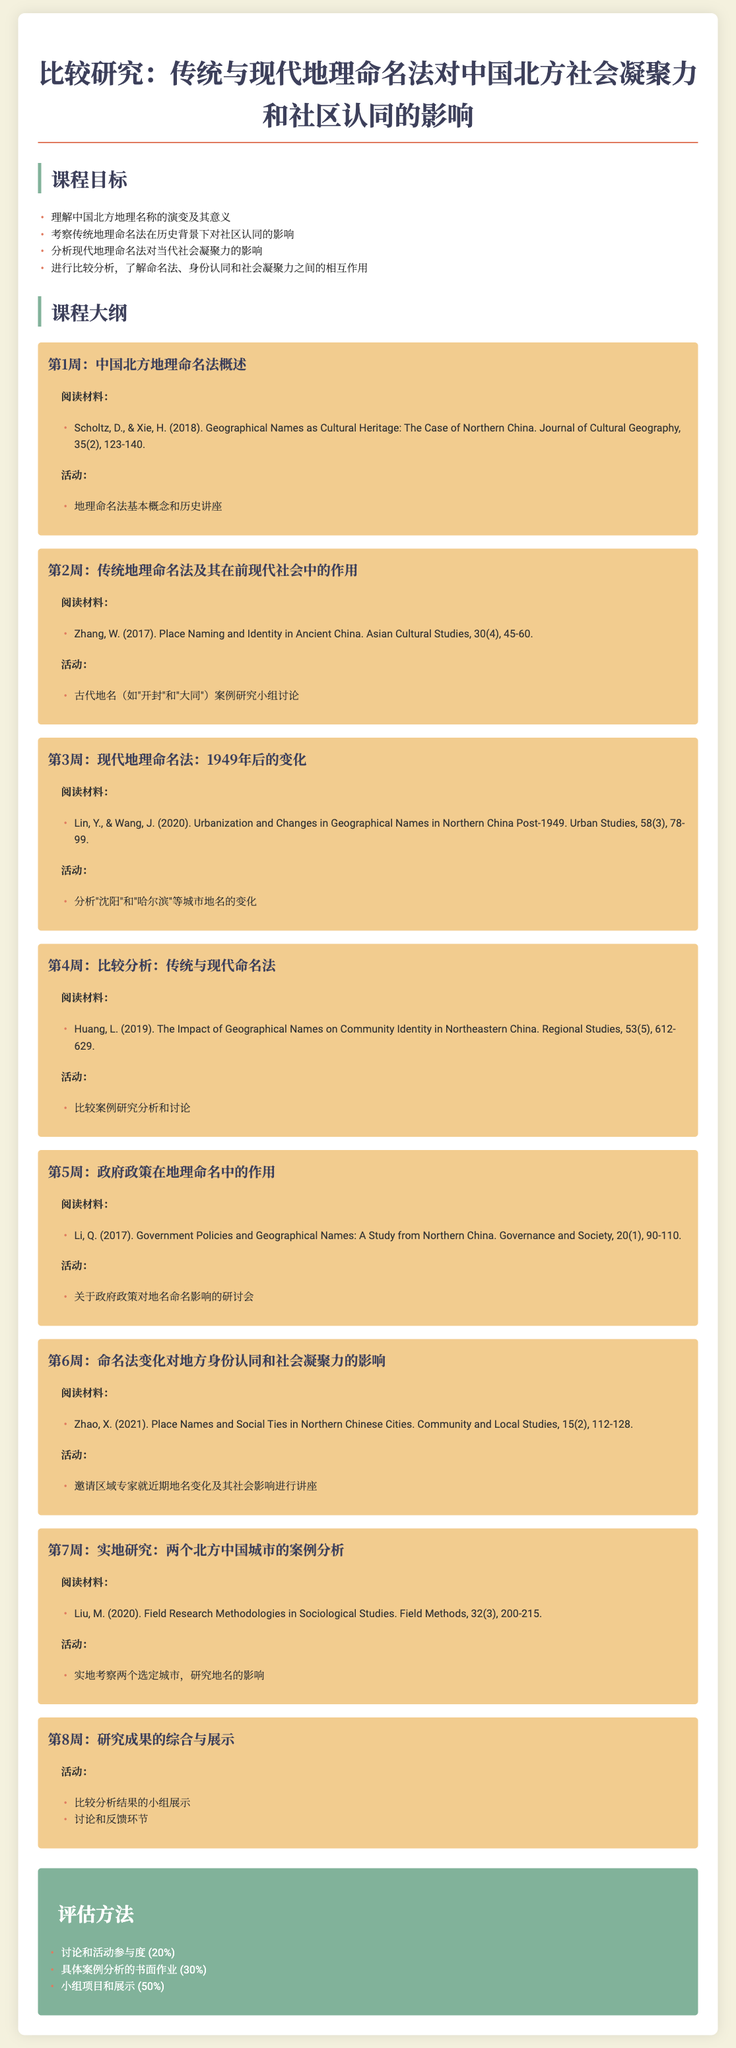什么是课程的主要目标？ 课程的主要目标包括理解地理名称的演变及其意义等四个方面。
Answer: 理解中国北方地理名称的演变及其意义 第1周的阅读材料是什么？ 第1周的阅读材料引用了Scholtz和Xie的文章，讨论了地理名称作为文化遗产的案例。
Answer: Scholtz, D., & Xie, H. (2018) 在第4周，学生将进行哪些活动？ 第4周的活动包括比较案例研究的分析和讨论，让学生实践学习。
Answer: 比较案例研究分析和讨论 哪位作者在第3周的阅读材料中讨论了城市化与地理名称的变化？ 第3周的阅读材料由Lin和Wang撰写，专注于1949年后的变化。
Answer: Lin, Y., & Wang, J 评估方法中占比最高的部分是什么？ 评估方法中小组项目和展示的占比为50%，这一比例是最高的。
Answer: 50% 